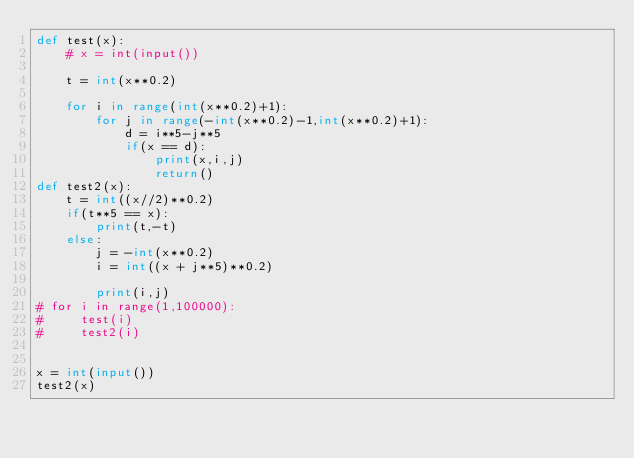<code> <loc_0><loc_0><loc_500><loc_500><_Python_>def test(x):
    # x = int(input())

    t = int(x**0.2)

    for i in range(int(x**0.2)+1):
        for j in range(-int(x**0.2)-1,int(x**0.2)+1):
            d = i**5-j**5
            if(x == d):
                print(x,i,j)
                return()
def test2(x):
    t = int((x//2)**0.2)
    if(t**5 == x):
        print(t,-t)
    else:
        j = -int(x**0.2)
        i = int((x + j**5)**0.2)

        print(i,j)
# for i in range(1,100000):
#     test(i)
#     test2(i)


x = int(input())
test2(x)</code> 